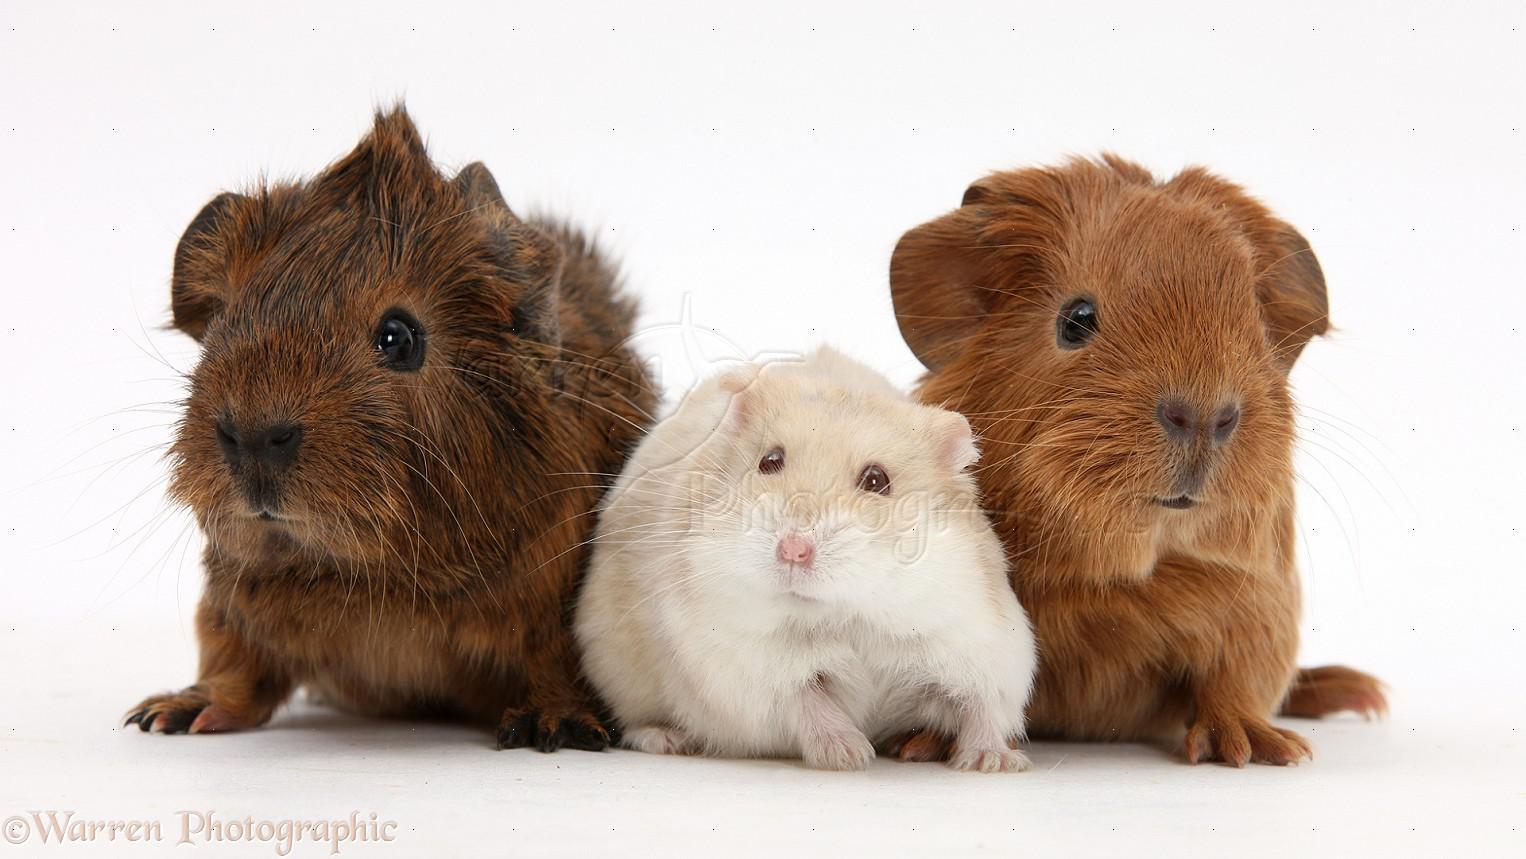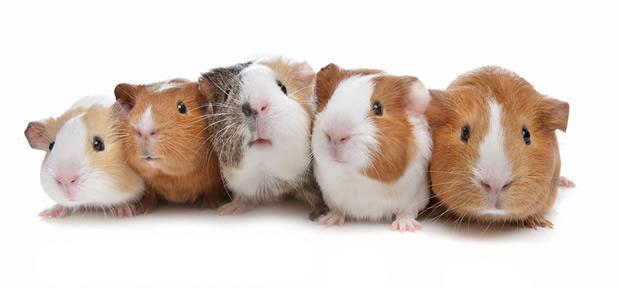The first image is the image on the left, the second image is the image on the right. Evaluate the accuracy of this statement regarding the images: "The right image contains exactly five guinea pigs in a horizontal row.". Is it true? Answer yes or no. Yes. The first image is the image on the left, the second image is the image on the right. Given the left and right images, does the statement "One image shows a horizontal row of five guinea pigs." hold true? Answer yes or no. Yes. 